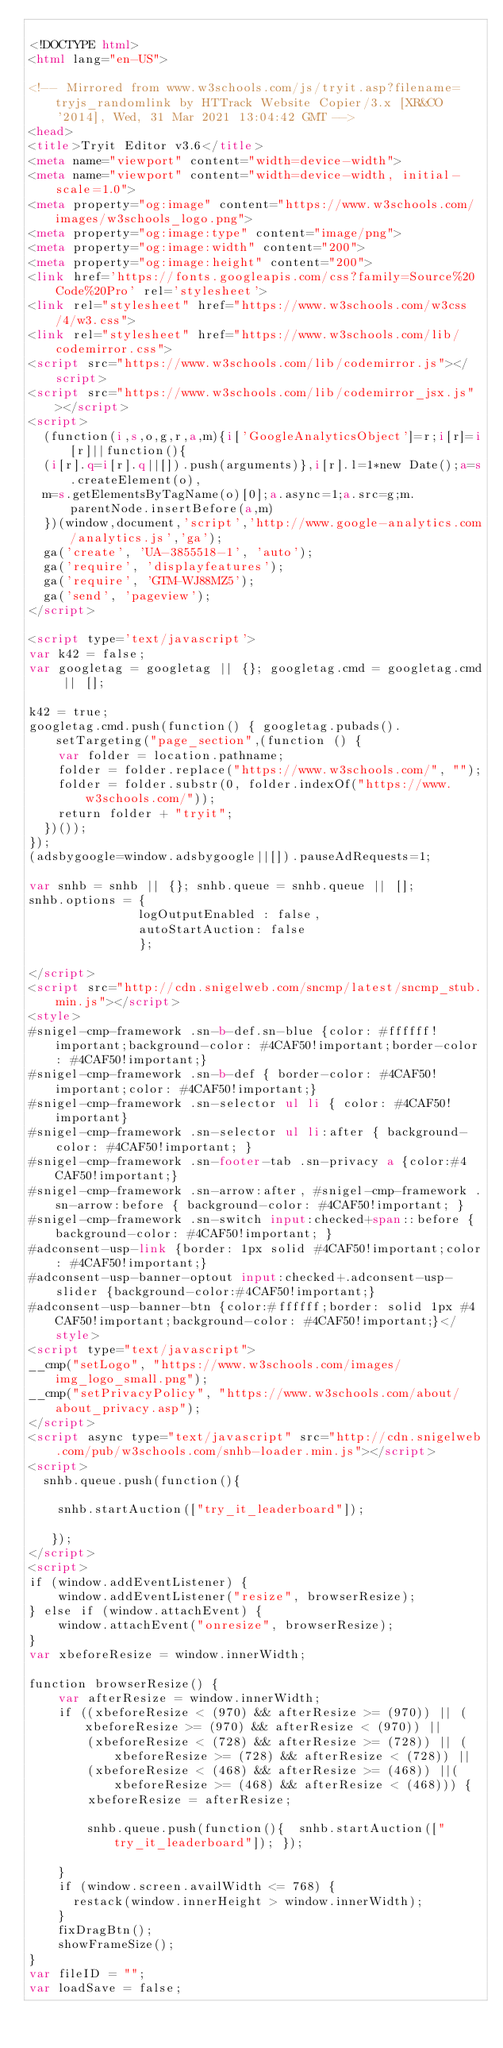Convert code to text. <code><loc_0><loc_0><loc_500><loc_500><_HTML_>
<!DOCTYPE html>
<html lang="en-US">

<!-- Mirrored from www.w3schools.com/js/tryit.asp?filename=tryjs_randomlink by HTTrack Website Copier/3.x [XR&CO'2014], Wed, 31 Mar 2021 13:04:42 GMT -->
<head>
<title>Tryit Editor v3.6</title>
<meta name="viewport" content="width=device-width">
<meta name="viewport" content="width=device-width, initial-scale=1.0">
<meta property="og:image" content="https://www.w3schools.com/images/w3schools_logo.png">
<meta property="og:image:type" content="image/png">
<meta property="og:image:width" content="200">
<meta property="og:image:height" content="200">
<link href='https://fonts.googleapis.com/css?family=Source%20Code%20Pro' rel='stylesheet'>
<link rel="stylesheet" href="https://www.w3schools.com/w3css/4/w3.css">
<link rel="stylesheet" href="https://www.w3schools.com/lib/codemirror.css">
<script src="https://www.w3schools.com/lib/codemirror.js"></script>
<script src="https://www.w3schools.com/lib/codemirror_jsx.js"></script>
<script>
  (function(i,s,o,g,r,a,m){i['GoogleAnalyticsObject']=r;i[r]=i[r]||function(){
  (i[r].q=i[r].q||[]).push(arguments)},i[r].l=1*new Date();a=s.createElement(o),
  m=s.getElementsByTagName(o)[0];a.async=1;a.src=g;m.parentNode.insertBefore(a,m)
  })(window,document,'script','http://www.google-analytics.com/analytics.js','ga');
  ga('create', 'UA-3855518-1', 'auto');
  ga('require', 'displayfeatures');
  ga('require', 'GTM-WJ88MZ5');
  ga('send', 'pageview');
</script>

<script type='text/javascript'>
var k42 = false;
var googletag = googletag || {}; googletag.cmd = googletag.cmd || [];

k42 = true;
googletag.cmd.push(function() { googletag.pubads().setTargeting("page_section",(function () {
    var folder = location.pathname;
    folder = folder.replace("https://www.w3schools.com/", "");
    folder = folder.substr(0, folder.indexOf("https://www.w3schools.com/"));
    return folder + "tryit";
  })());
});  
(adsbygoogle=window.adsbygoogle||[]).pauseAdRequests=1;

var snhb = snhb || {}; snhb.queue = snhb.queue || [];
snhb.options = {
               logOutputEnabled : false,
               autoStartAuction: false
               };

</script>
<script src="http://cdn.snigelweb.com/sncmp/latest/sncmp_stub.min.js"></script>
<style>
#snigel-cmp-framework .sn-b-def.sn-blue {color: #ffffff!important;background-color: #4CAF50!important;border-color: #4CAF50!important;}
#snigel-cmp-framework .sn-b-def { border-color: #4CAF50!important;color: #4CAF50!important;}
#snigel-cmp-framework .sn-selector ul li { color: #4CAF50!important}
#snigel-cmp-framework .sn-selector ul li:after { background-color: #4CAF50!important; }
#snigel-cmp-framework .sn-footer-tab .sn-privacy a {color:#4CAF50!important;}
#snigel-cmp-framework .sn-arrow:after, #snigel-cmp-framework .sn-arrow:before { background-color: #4CAF50!important; }
#snigel-cmp-framework .sn-switch input:checked+span::before { background-color: #4CAF50!important; }
#adconsent-usp-link {border: 1px solid #4CAF50!important;color: #4CAF50!important;}
#adconsent-usp-banner-optout input:checked+.adconsent-usp-slider {background-color:#4CAF50!important;}
#adconsent-usp-banner-btn {color:#ffffff;border: solid 1px #4CAF50!important;background-color: #4CAF50!important;}</style>
<script type="text/javascript">
__cmp("setLogo", "https://www.w3schools.com/images/img_logo_small.png");
__cmp("setPrivacyPolicy", "https://www.w3schools.com/about/about_privacy.asp");
</script>
<script async type="text/javascript" src="http://cdn.snigelweb.com/pub/w3schools.com/snhb-loader.min.js"></script>
<script>
  snhb.queue.push(function(){

    snhb.startAuction(["try_it_leaderboard"]);

   });
</script>
<script>
if (window.addEventListener) {              
    window.addEventListener("resize", browserResize);
} else if (window.attachEvent) {                 
    window.attachEvent("onresize", browserResize);
}
var xbeforeResize = window.innerWidth;

function browserResize() {
    var afterResize = window.innerWidth;
    if ((xbeforeResize < (970) && afterResize >= (970)) || (xbeforeResize >= (970) && afterResize < (970)) ||
        (xbeforeResize < (728) && afterResize >= (728)) || (xbeforeResize >= (728) && afterResize < (728)) ||
        (xbeforeResize < (468) && afterResize >= (468)) ||(xbeforeResize >= (468) && afterResize < (468))) {
        xbeforeResize = afterResize;
        
        snhb.queue.push(function(){  snhb.startAuction(["try_it_leaderboard"]); });
         
    }
    if (window.screen.availWidth <= 768) {
      restack(window.innerHeight > window.innerWidth);
    }
    fixDragBtn();
    showFrameSize();    
}
var fileID = "";
var loadSave = false;</code> 